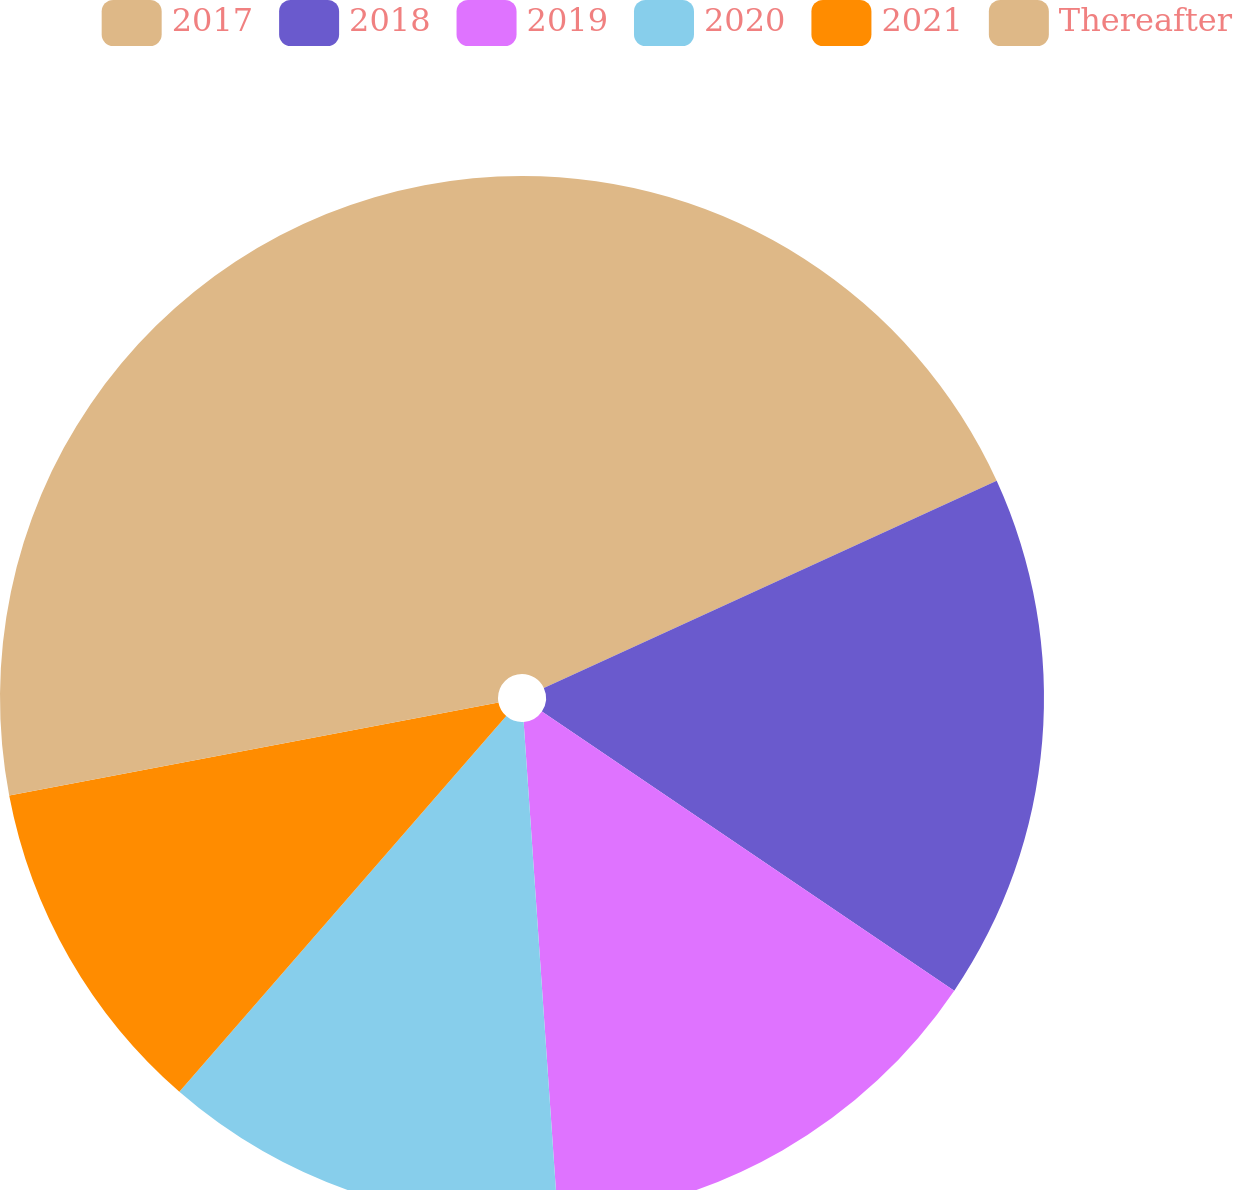<chart> <loc_0><loc_0><loc_500><loc_500><pie_chart><fcel>2017<fcel>2018<fcel>2019<fcel>2020<fcel>2021<fcel>Thereafter<nl><fcel>18.17%<fcel>16.3%<fcel>14.43%<fcel>12.49%<fcel>10.61%<fcel>27.99%<nl></chart> 